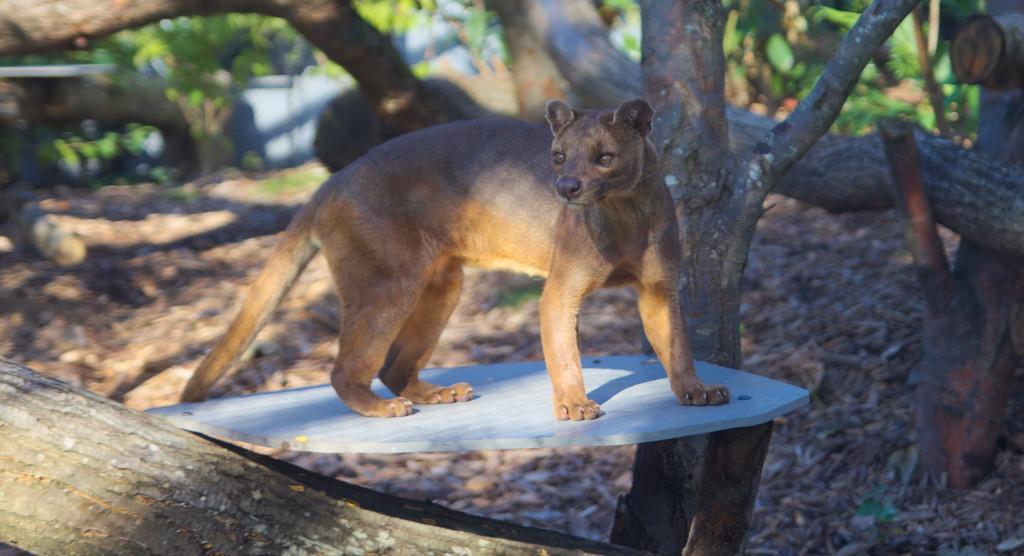What animal is in the center of the image? There is a fox in the center of the image. What type of natural environment is depicted in the image? There are trees around the area of the image, suggesting a forest or woodland setting. What type of crime is being committed by the fox in the image? There is no crime being committed by the fox in the image; it is simply depicted in its natural environment. 